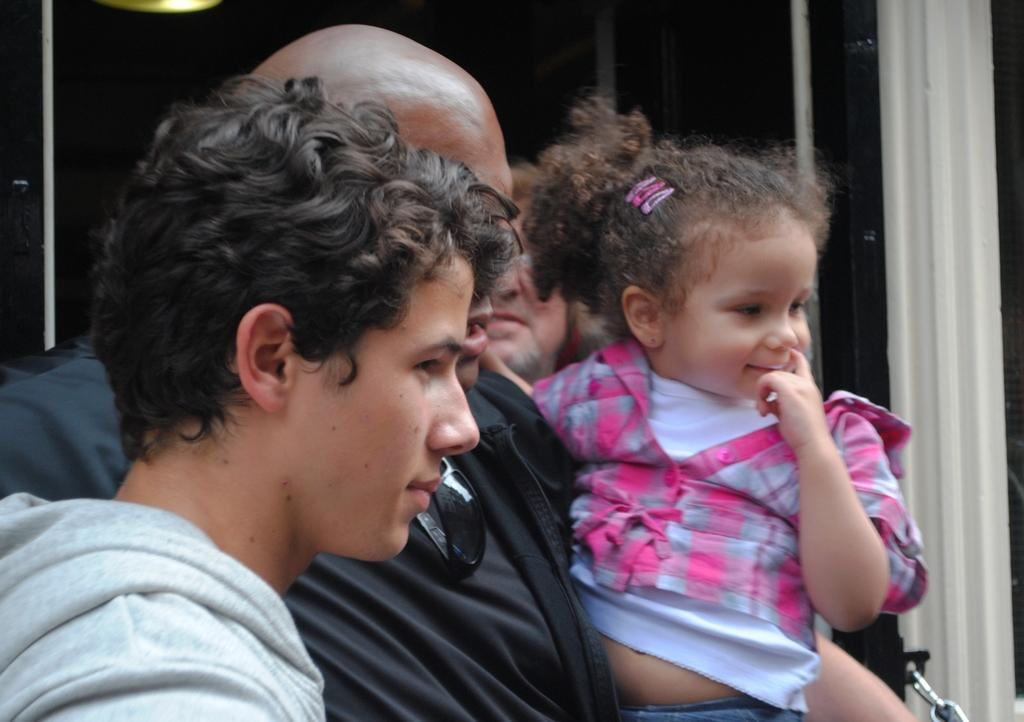How many people are in the image? There are persons in the image, but the exact number cannot be determined from the provided facts. What else can be seen in the image besides the persons? There are other objects in the background of the image. What type of twig is being used by the person in the image? There is no mention of a twig in the image, so it cannot be determined if a twig is present or being used by a person. 